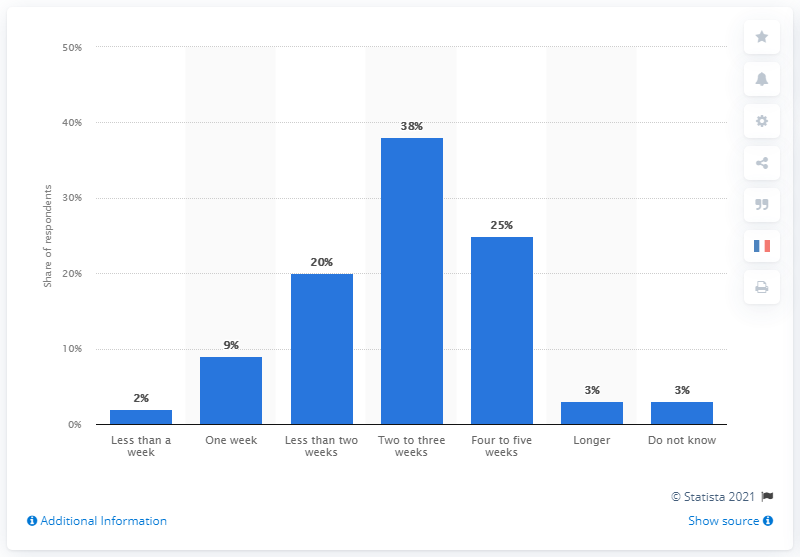Draw attention to some important aspects in this diagram. According to a survey of moviegoers, a significant percentage believed that a movie typically stays in theaters for two to three weeks. 